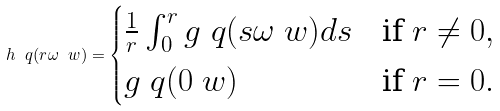<formula> <loc_0><loc_0><loc_500><loc_500>h \ q ( r \omega \ w ) = \begin{cases} \frac { 1 } { r } \int _ { 0 } ^ { r } g \ q ( s \omega \ w ) d s & \text {if $r\ne 0$} , \\ g \ q ( 0 \ w ) & \text {if $r=0$} . \end{cases}</formula> 